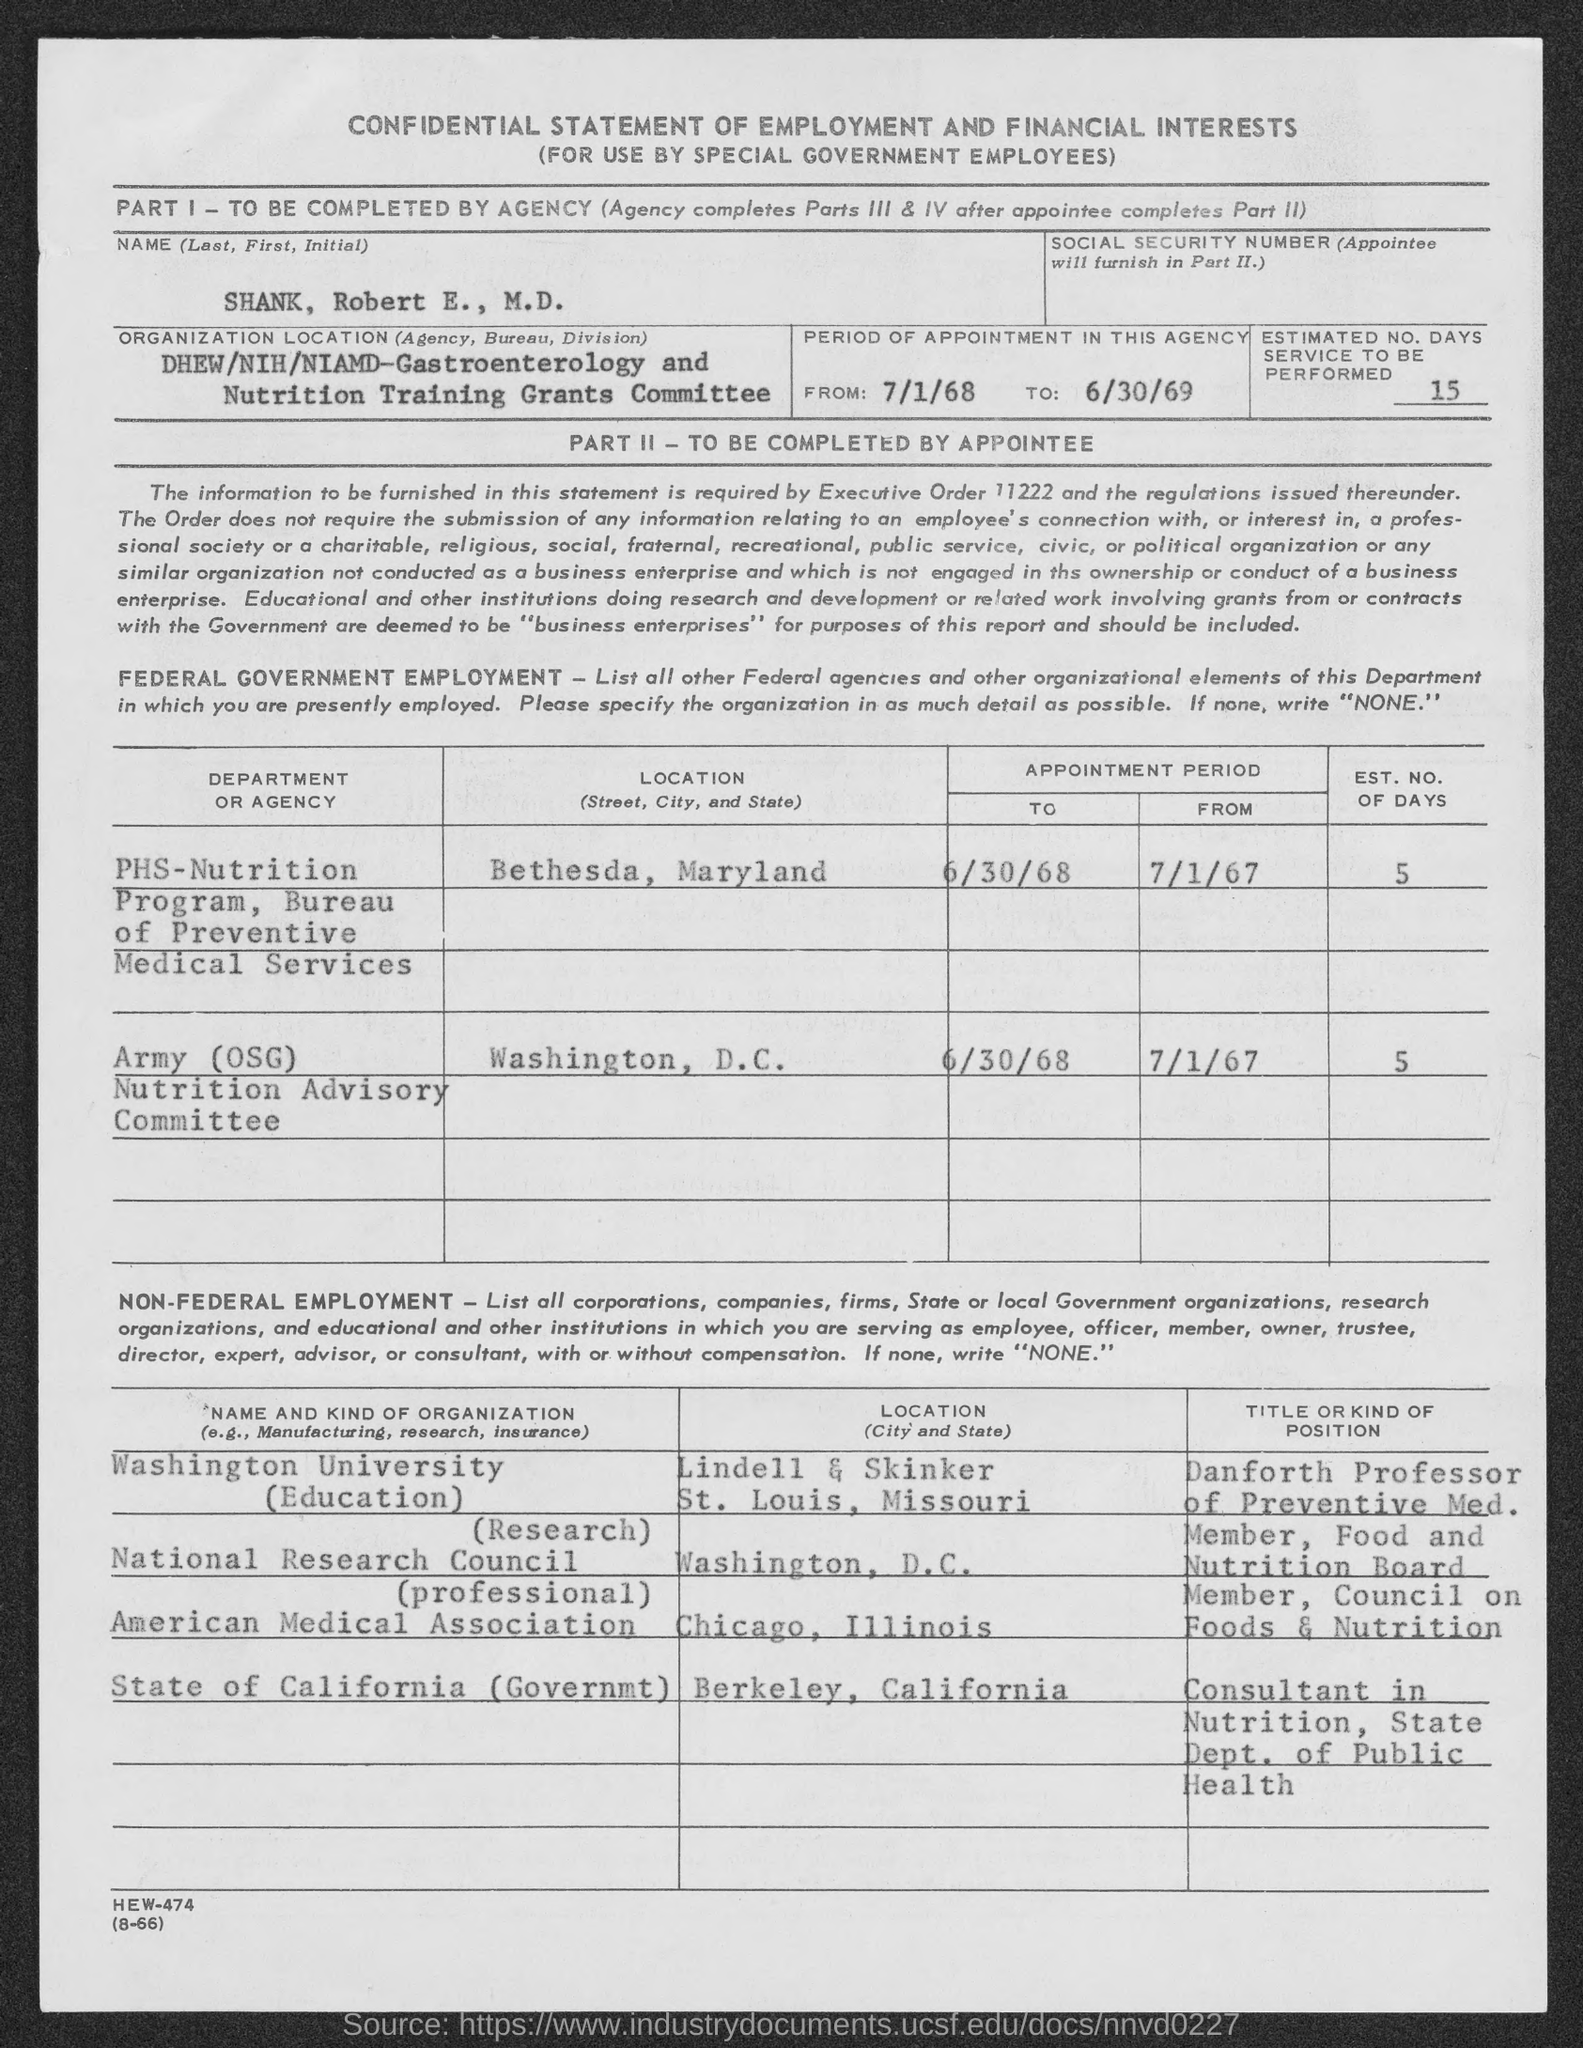Indicate a few pertinent items in this graphic. We will provide an estimated number of days required to complete the service, ranging from 15 to... The EST. NO OF DAYS of the Army(OSG) Nutrition Advisory Committee is 5. The location of Washington University, specifically at Lindell & Skinker in St. Louis, Missouri, has been provided. The location of the PHS-NUTRITION Program in Bethesda, Maryland, has been provided. The location of the National Research Council is in Washington, D.C. 